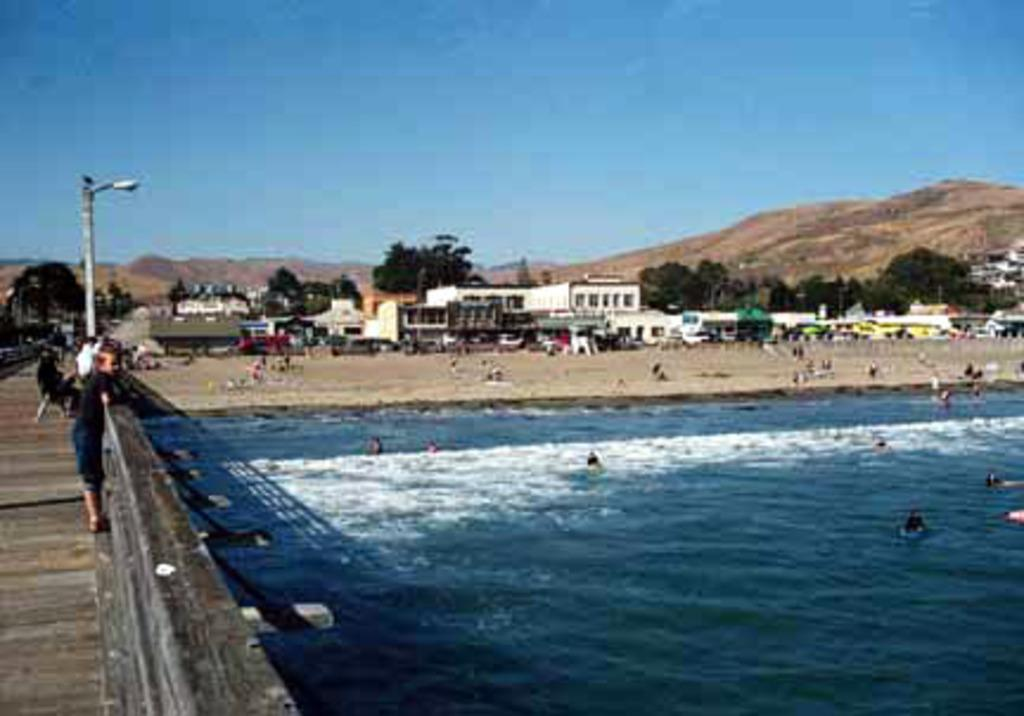What are the people in the image doing? There are people in the water and people on the ground in the image. What structures can be seen in the image? There are buildings in the image. What type of natural environment is visible in the image? There are trees and mountains in the image. What is visible in the background of the image? The sky is visible in the background of the image. What type of error can be seen in the image? There is no error present in the image. What type of cast can be seen in the image? There is no cast present in the image. 